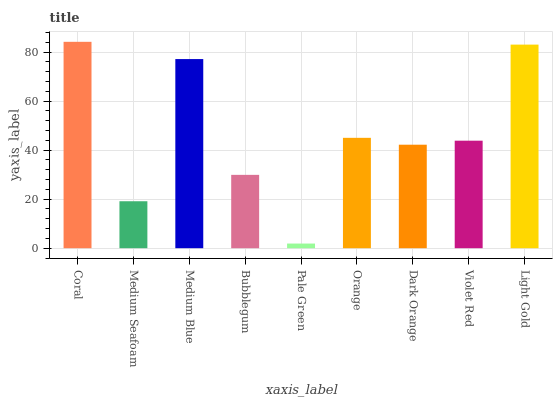Is Pale Green the minimum?
Answer yes or no. Yes. Is Coral the maximum?
Answer yes or no. Yes. Is Medium Seafoam the minimum?
Answer yes or no. No. Is Medium Seafoam the maximum?
Answer yes or no. No. Is Coral greater than Medium Seafoam?
Answer yes or no. Yes. Is Medium Seafoam less than Coral?
Answer yes or no. Yes. Is Medium Seafoam greater than Coral?
Answer yes or no. No. Is Coral less than Medium Seafoam?
Answer yes or no. No. Is Violet Red the high median?
Answer yes or no. Yes. Is Violet Red the low median?
Answer yes or no. Yes. Is Pale Green the high median?
Answer yes or no. No. Is Orange the low median?
Answer yes or no. No. 